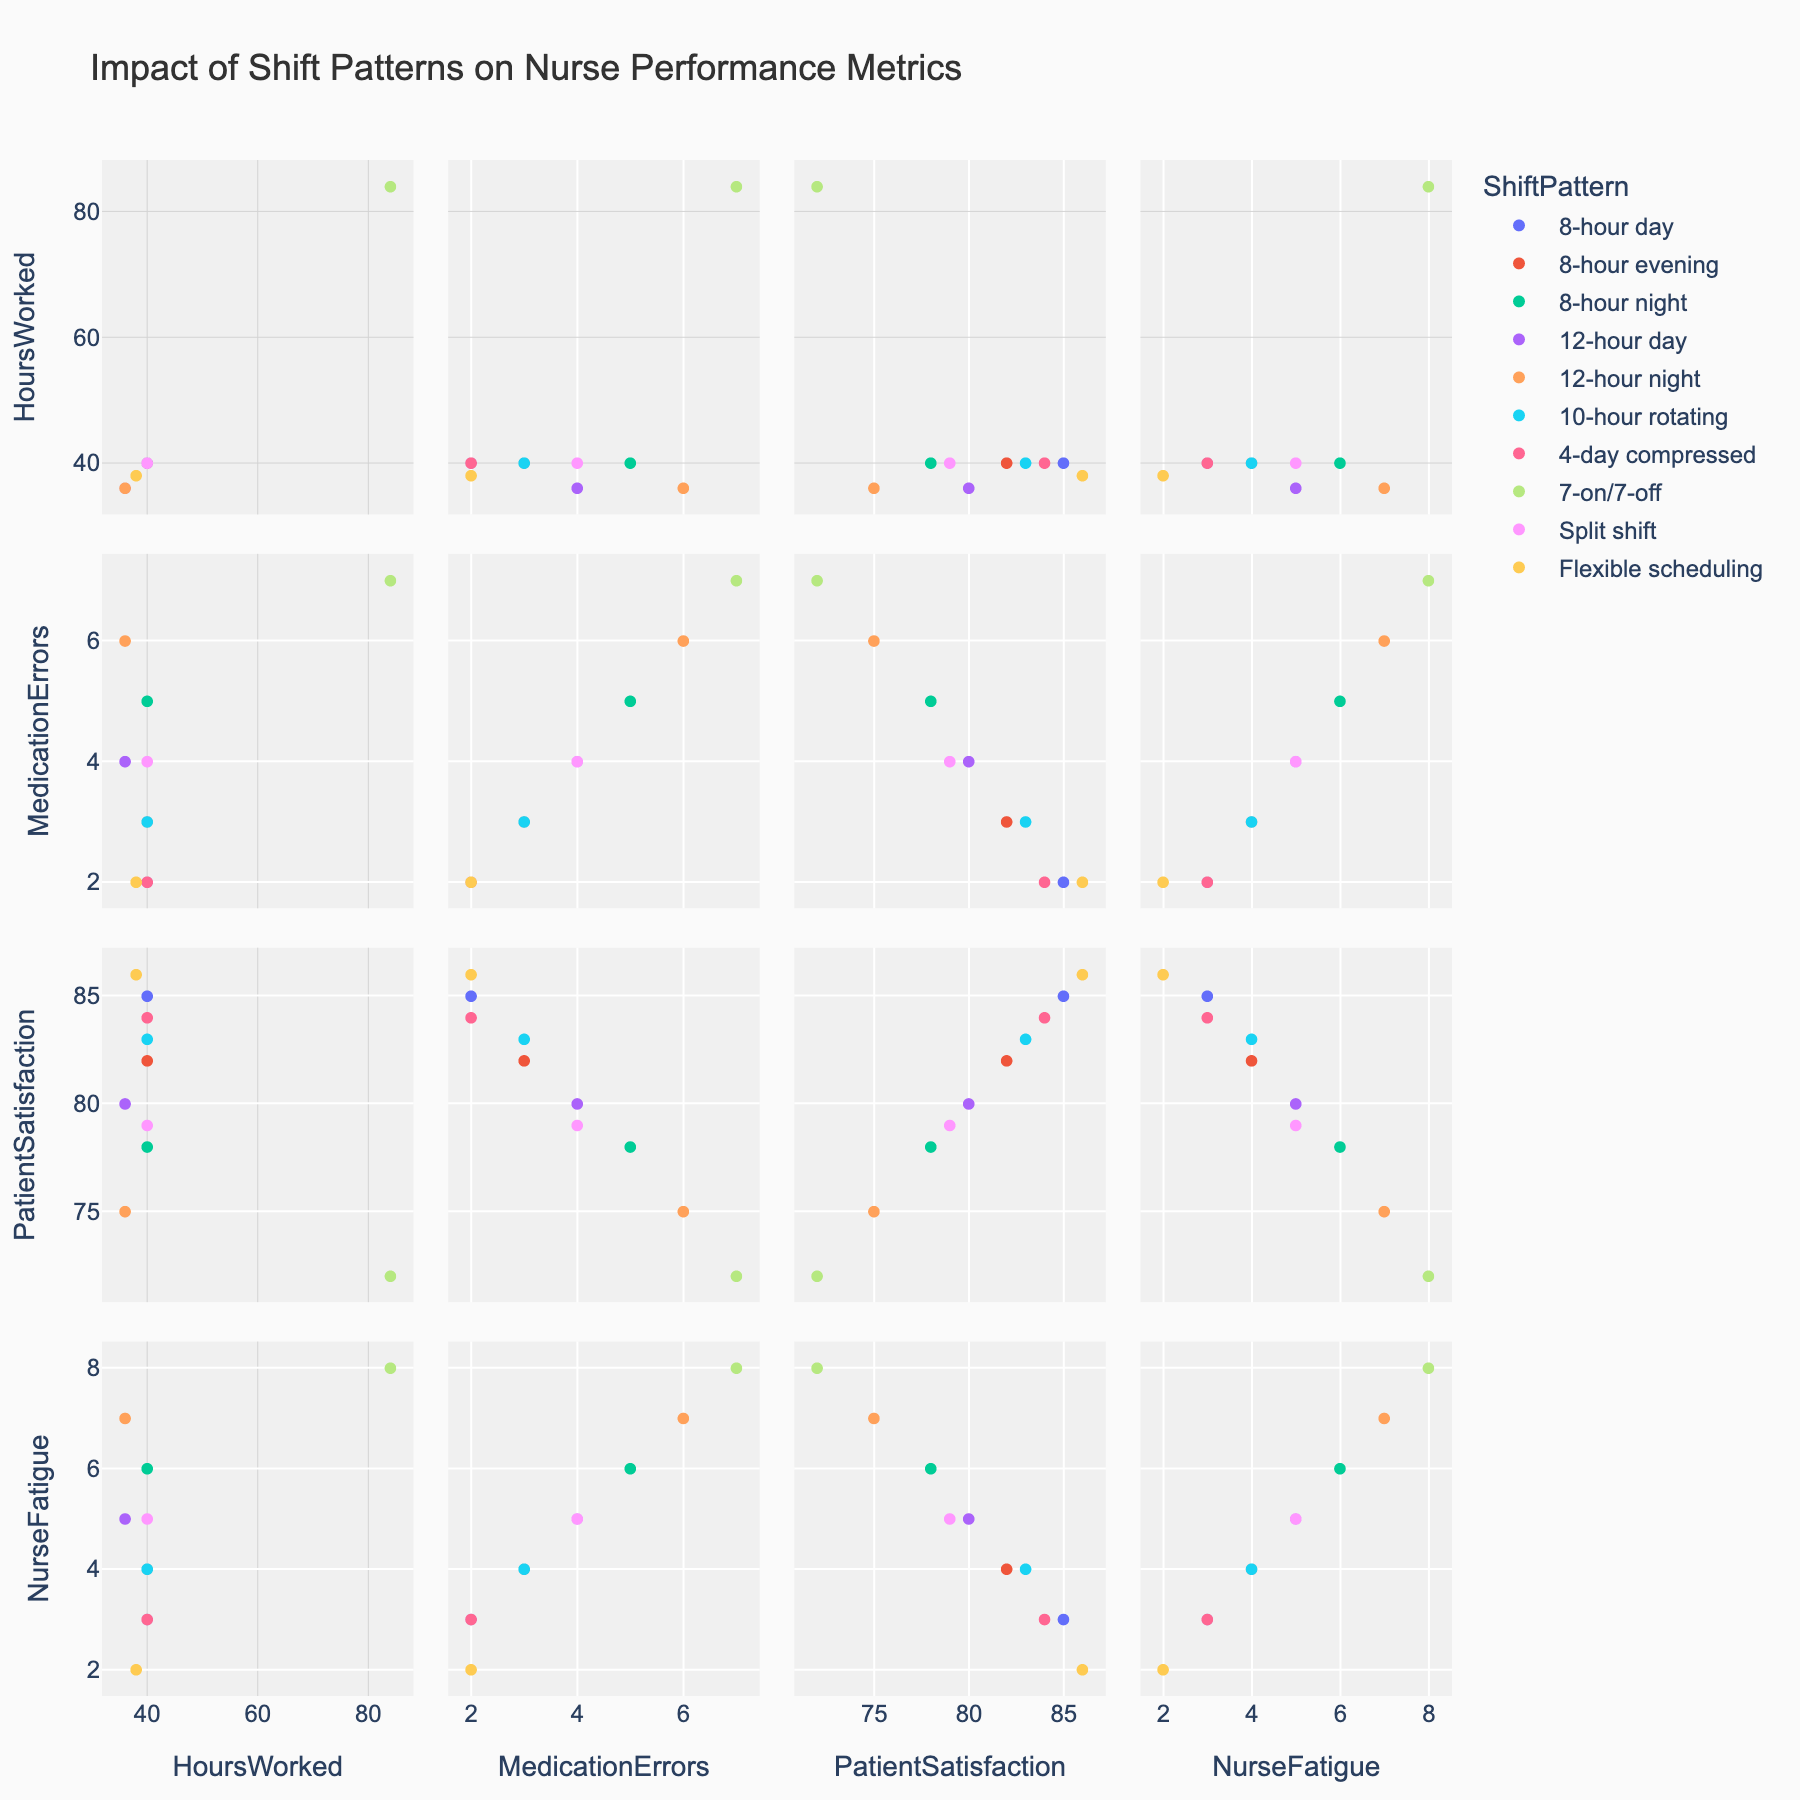What is the title of the figure? The title is displayed at the top of the figure, visually summarizing the content
Answer: Impact of Shift Patterns on Nurse Performance Metrics How many shift patterns are represented in the data? By examining the color legend, you can count the different unique shift patterns shown
Answer: 10 Which shift pattern has the highest patient satisfaction score? Look at the 'Patient Satisfaction' axis and identify the highest point, then check its corresponding shift pattern based on the color/code
Answer: Flexible scheduling Which shift pattern has the highest medication errors? Look at the 'Medication Errors' axis and identify the highest point, then identify its corresponding shift pattern
Answer: 7-on/7-off For the shift pattern with the highest nurse fatigue, what is the corresponding hours worked? Identify the data point with the highest 'Nurse Fatigue' and then check the corresponding value for 'Hours Worked'
Answer: 84 What is the relationship between hours worked and nurse fatigue? Observe the scatterplots involving 'Hours Worked' and 'Nurse Fatigue' to check if the trend shows a positive or negative correlation
Answer: Positive correlation Which shift patterns have no more than 3 medication errors and higher than 80 in patient satisfaction scores? Filter through scatterplots to find patterns that meet both conditions by checking 'Medication Errors' ≤ 3 and 'Patient Satisfaction' > 80
Answer: 8-hour day, 4-day compressed, Flexible scheduling Does the 12-hour night shift have more medication errors than the 8-hour evening shift? Compare the number of medication errors specifically between these two shift patterns by examining their data points
Answer: Yes Which shift pattern appears to have the least nurse fatigue and the maximum patient satisfaction? Identify the points with the lowest value on the 'Nurse Fatigue' axis and the highest on the 'Patient Satisfaction' axis; find the one meeting both conditions
Answer: Flexible scheduling Does nurse fatigue correlate more strongly with hours worked or medication errors? Compare the scatterplots of 'Nurse Fatigue' vs. 'Hours Worked' and 'Nurse Fatigue' vs. 'Medication Errors' to determine which one shows a stronger apparent trend
Answer: Hours worked 